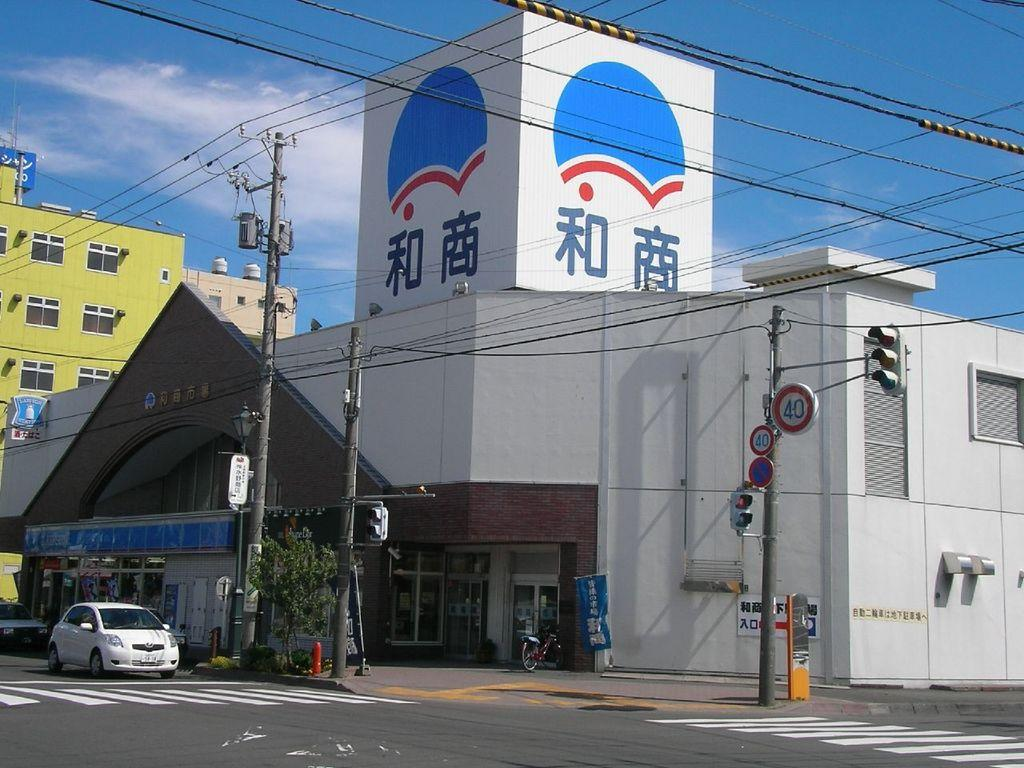What type of structures can be seen in the image? There are buildings in the image. What other objects can be seen in the image? There are poles, boards, a bicycle, a traffic signal, plants, a tree, cars, and wires visible in the image. What is visible in the background of the image? The sky is visible in the background of the image. What type of care is being provided to the tree in the image? There is no indication in the image that any care is being provided to the tree. What color is the shirt worn by the branch in the image? There is no branch or shirt present in the image. 